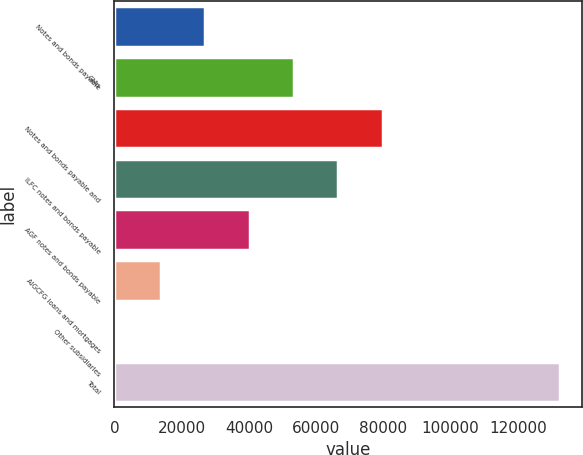Convert chart to OTSL. <chart><loc_0><loc_0><loc_500><loc_500><bar_chart><fcel>Notes and bonds payable<fcel>GIAs<fcel>Notes and bonds payable and<fcel>ILFC notes and bonds payable<fcel>AGF notes and bonds payable<fcel>AIGCFG loans and mortgages<fcel>Other subsidiaries<fcel>Total<nl><fcel>27049.2<fcel>53426.4<fcel>79803.6<fcel>66615<fcel>40237.8<fcel>13860.6<fcel>672<fcel>132558<nl></chart> 